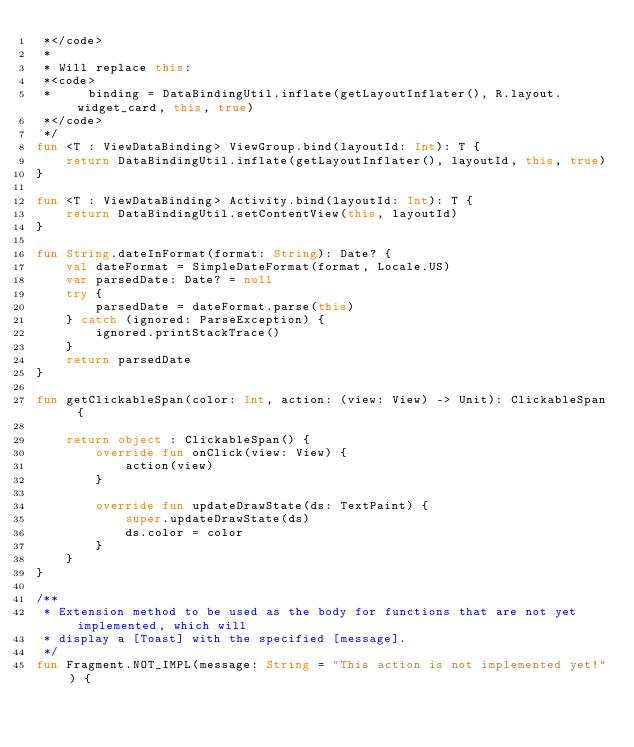<code> <loc_0><loc_0><loc_500><loc_500><_Kotlin_> *</code>
 *
 * Will replace this:
 *<code>
 *     binding = DataBindingUtil.inflate(getLayoutInflater(), R.layout.widget_card, this, true)
 *</code>
 */
fun <T : ViewDataBinding> ViewGroup.bind(layoutId: Int): T {
    return DataBindingUtil.inflate(getLayoutInflater(), layoutId, this, true)
}

fun <T : ViewDataBinding> Activity.bind(layoutId: Int): T {
    return DataBindingUtil.setContentView(this, layoutId)
}

fun String.dateInFormat(format: String): Date? {
    val dateFormat = SimpleDateFormat(format, Locale.US)
    var parsedDate: Date? = null
    try {
        parsedDate = dateFormat.parse(this)
    } catch (ignored: ParseException) {
        ignored.printStackTrace()
    }
    return parsedDate
}

fun getClickableSpan(color: Int, action: (view: View) -> Unit): ClickableSpan {

    return object : ClickableSpan() {
        override fun onClick(view: View) {
            action(view)
        }

        override fun updateDrawState(ds: TextPaint) {
            super.updateDrawState(ds)
            ds.color = color
        }
    }
}

/**
 * Extension method to be used as the body for functions that are not yet implemented, which will
 * display a [Toast] with the specified [message].
 */
fun Fragment.NOT_IMPL(message: String = "This action is not implemented yet!") {</code> 